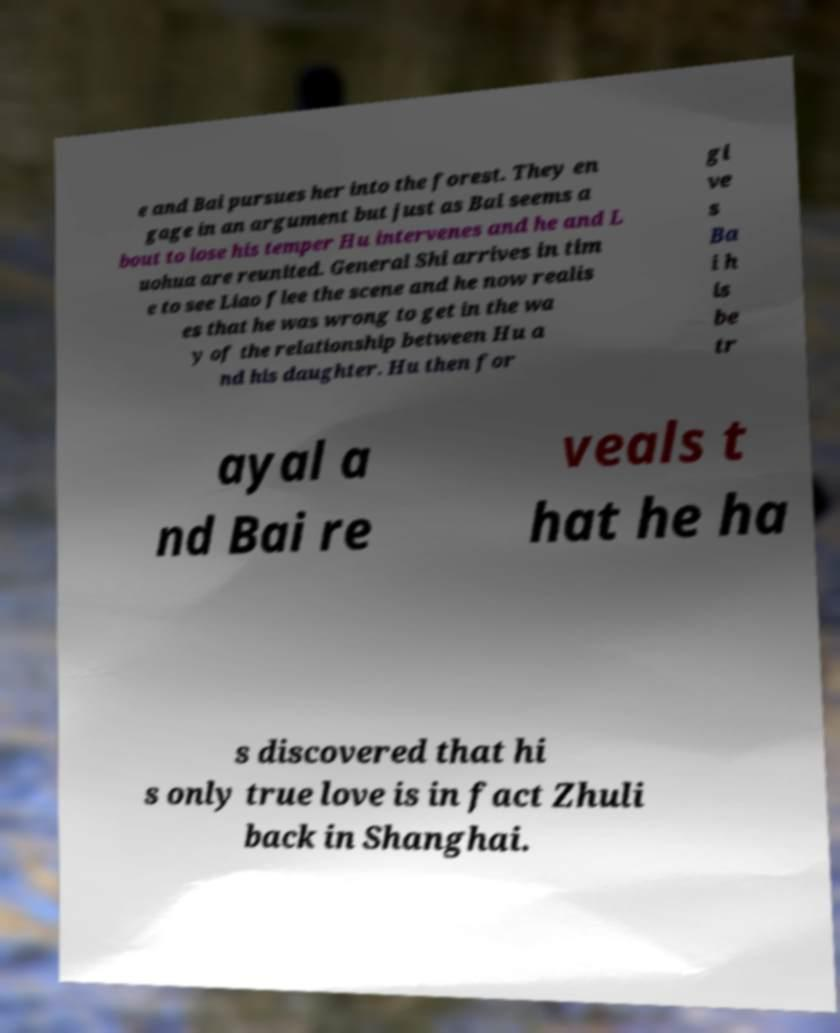There's text embedded in this image that I need extracted. Can you transcribe it verbatim? e and Bai pursues her into the forest. They en gage in an argument but just as Bai seems a bout to lose his temper Hu intervenes and he and L uohua are reunited. General Shi arrives in tim e to see Liao flee the scene and he now realis es that he was wrong to get in the wa y of the relationship between Hu a nd his daughter. Hu then for gi ve s Ba i h is be tr ayal a nd Bai re veals t hat he ha s discovered that hi s only true love is in fact Zhuli back in Shanghai. 